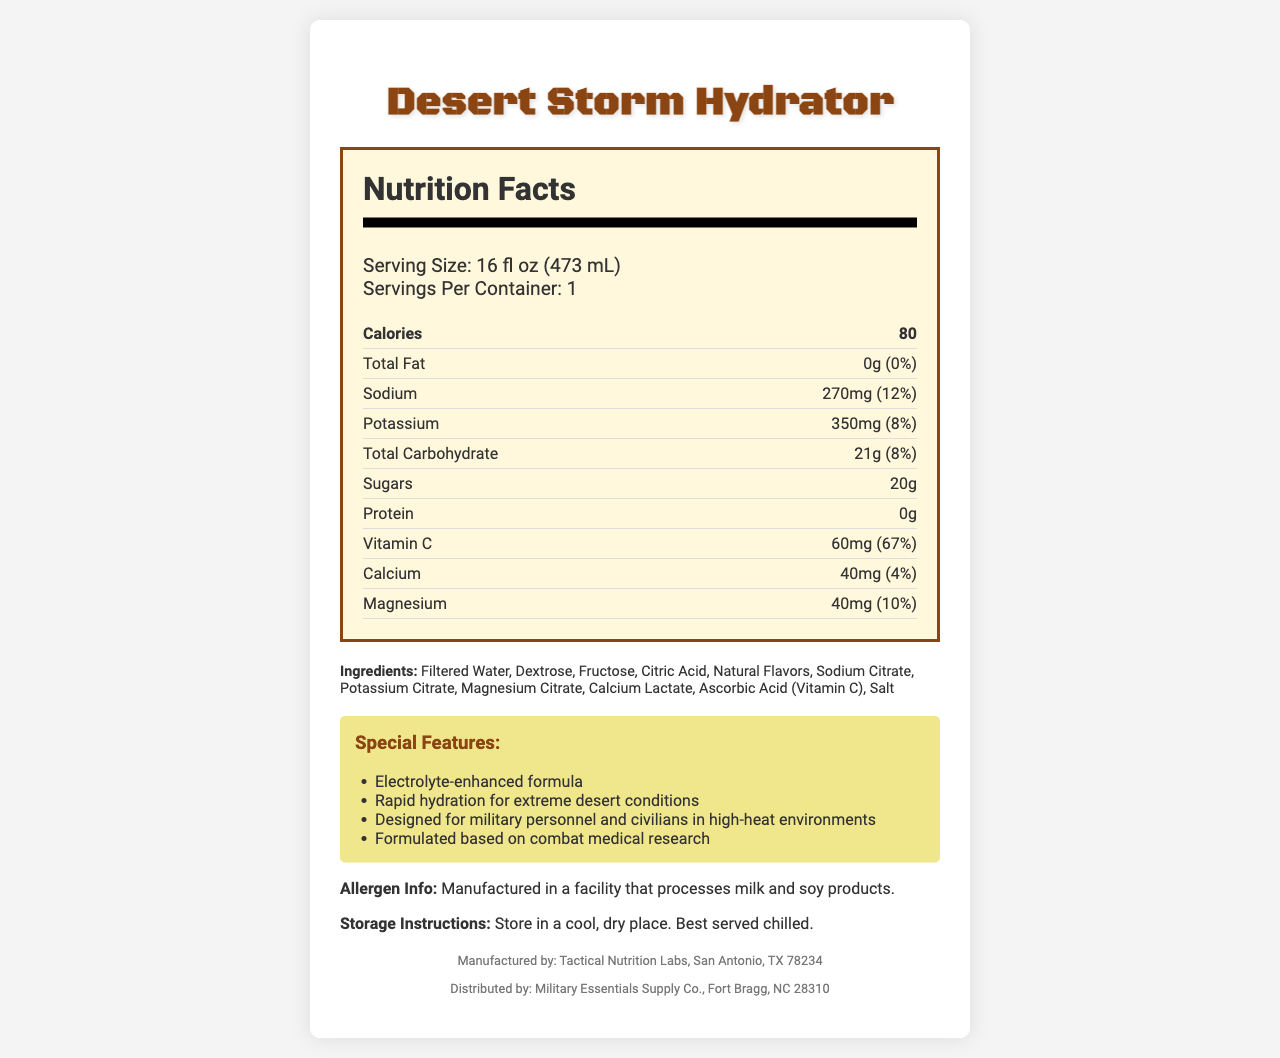what is the serving size of Desert Storm Hydrator? The serving size is listed as "16 fl oz (473 mL)" on the document.
Answer: 16 fl oz (473 mL) how many calories are in the Desert Storm Hydrator? The document states that there are 80 calories in the product.
Answer: 80 what is the amount of sodium in one serving? The document specifies that the sodium content per serving is 270mg.
Answer: 270mg how much Vitamin C is present in one serving? The document mentions that each serving contains 60mg of Vitamin C.
Answer: 60mg what percentage of daily value of potassium does the beverage provide? The document presents that potassium contributes 8% of the daily value per serving.
Answer: 8% what are the total carbohydrates in one serving? The total carbohydrate content per serving is 21g as listed in the document.
Answer: 21g what minerals are included in the Desert Storm Hydrator? According to the document, the minerals included are sodium, potassium, calcium, and magnesium.
Answer: Sodium, Potassium, Calcium, Magnesium where is the Desert Storm Hydrator manufactured? The document states it is manufactured by Tactical Nutrition Labs in San Antonio, TX 78234.
Answer: San Antonio, TX 78234 what are the top three ingredients in the Desert Storm Hydrator? The top three ingredients are listed as Filtered Water, Dextrose, and Fructose.
Answer: Filtered Water, Dextrose, Fructose which of the following special features is NOT mentioned in the document? A. Electrolyte-enhanced formula B. Rapid hydration for extreme desert conditions C. Contains caffeine D. Formulated based on combat medical research The document lists the special features, and 'Contains caffeine' is not one of them.
Answer: C. Contains caffeine how many grams of protein does the Desert Storm Hydrator have? The document mentions that there are 0g of protein in the product.
Answer: 0g how many sugars are in one serving? The document lists 20g of sugars per serving.
Answer: 20g the product is recommended to be served chilled. True or False? According to the storage instructions, the product is best served chilled.
Answer: True can you consume this product if you have a severe allergy to soy? The allergen info indicates that the product is manufactured in a facility that processes milk and soy products.
Answer: Consume with caution summarize the main nutritional benefits of Desert Storm Hydrator. The document highlights the formulation of the hydration beverage based on combat medical research, its rapid hydration properties for extreme conditions, and significant contributions to daily values of essential nutrients.
Answer: The Desert Storm Hydrator offers rapid hydration with an electrolyte-enhanced formula designed for extreme desert conditions. It provides essential minerals such as sodium, potassium, calcium, and magnesium. It also contains 60mg of Vitamin C, which is 67% of the daily value, making it beneficial for combating the harsh conditions of desert environments. does the Desert Storm Hydrator contain artificial flavors? The document only mentions "Natural Flavors" but does not address the presence of artificial flavors explicitly.
Answer: Not enough information 